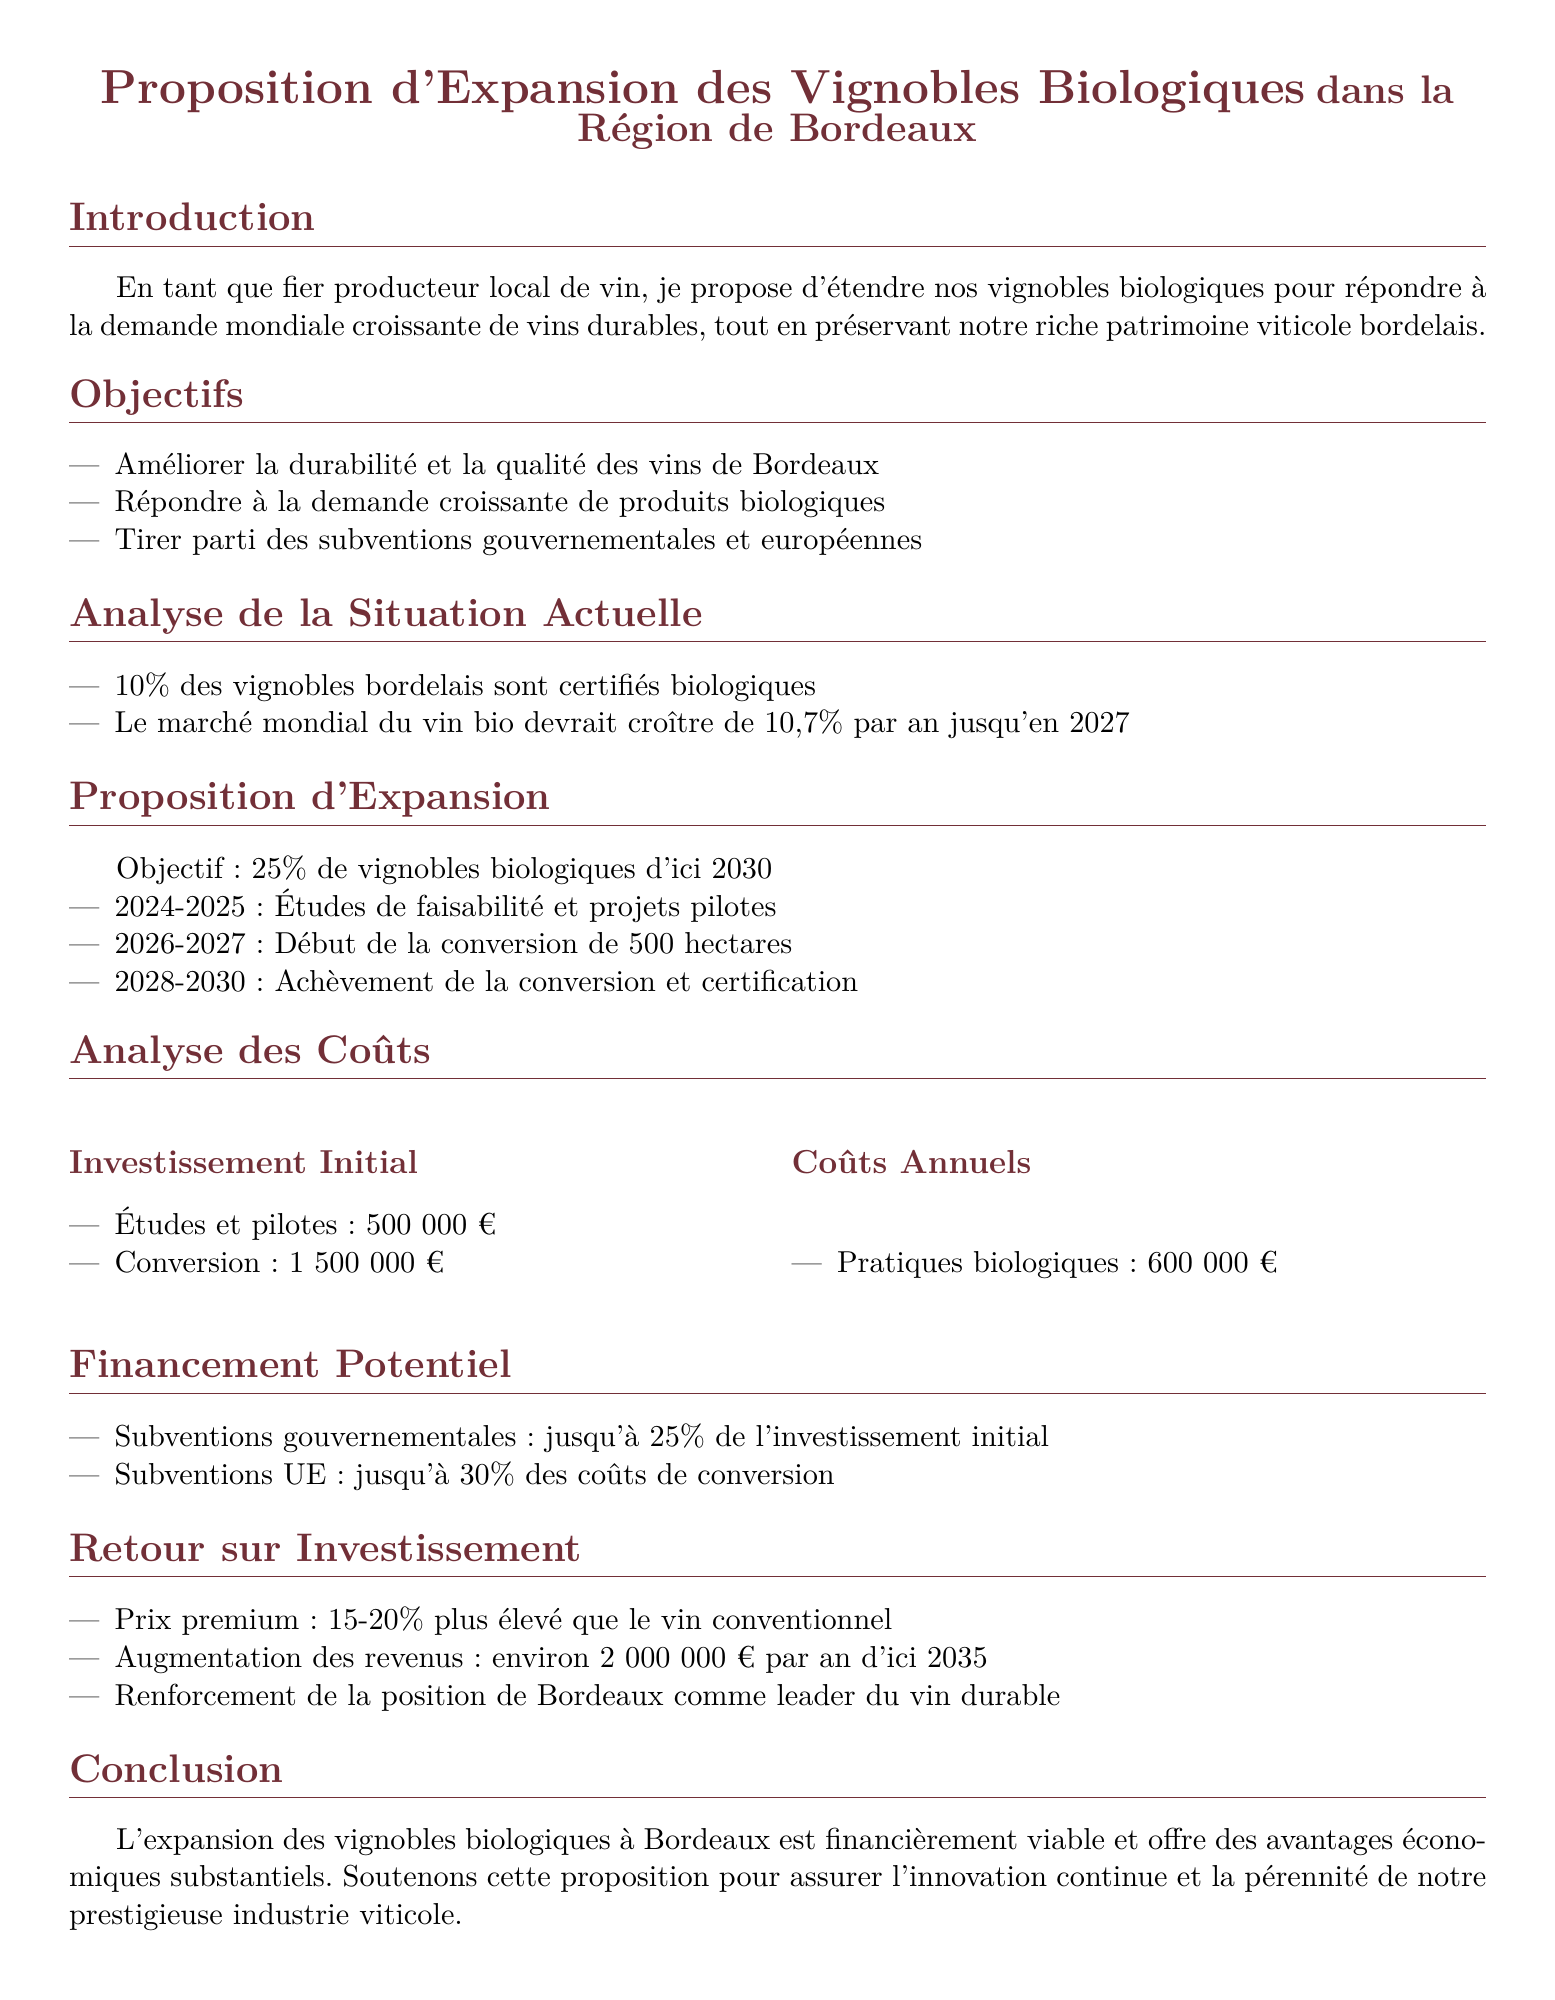Quel pourcentage des vignobles bordelais est certifié biologique ? Le document indique que 10% des vignobles bordelais sont certifiés biologiques.
Answer: 10% Quel est le coût initial total d'investissement pour l'expansion ? La proposition mentionne un investissement initial total de 500 000 € pour les études et 1 500 000 € pour la conversion, soit un total de 2 000 000 €.
Answer: 2 000 000 € Quelle est la durée estimée pour atteindre l'objectif de 25 % de vignobles biologiques ? Selon la proposition, l'objectif devrait être atteint d'ici 2030.
Answer: 2030 Quel est le pourcentage d'augmentation des revenus prévu d'ici 2035 ? Le document prévoit une augmentation des revenus d'environ 2 000 000 € par an d'ici 2035.
Answer: 2 000 000 € Quelle est la subvention gouvernementale maximale disponible pour l'investissement initial ? Il est mentionné que les subventions gouvernementales peuvent aller jusqu'à 25 % de l'investissement initial.
Answer: 25% Quels types de pratiques sont associées aux coûts annuels ? Le document indique que les pratiques biologiques engendrent des coûts annuels de 600 000 €.
Answer: 600 000 € Quel est l'objectif principal de la proposition ? L'objectif principal est d'étendre les vignobles biologiques en réponse à la demande croissante.
Answer: Répondre à la demande croissante de produits biologiques Quel est le pourcentage de croissance prévu pour le marché mondial du vin bio d'ici 2027 ? Le document affirme que le marché mondial du vin bio devrait croître de 10,7 % par an jusqu'en 2027.
Answer: 10,7 % Quels sous-chapitres sont présents dans la section d'analyse des coûts ? Les sous-chapitres incluent "Investissement Initial" et "Coûts Annuels".
Answer: Investissement Initial, Coûts Annuels 